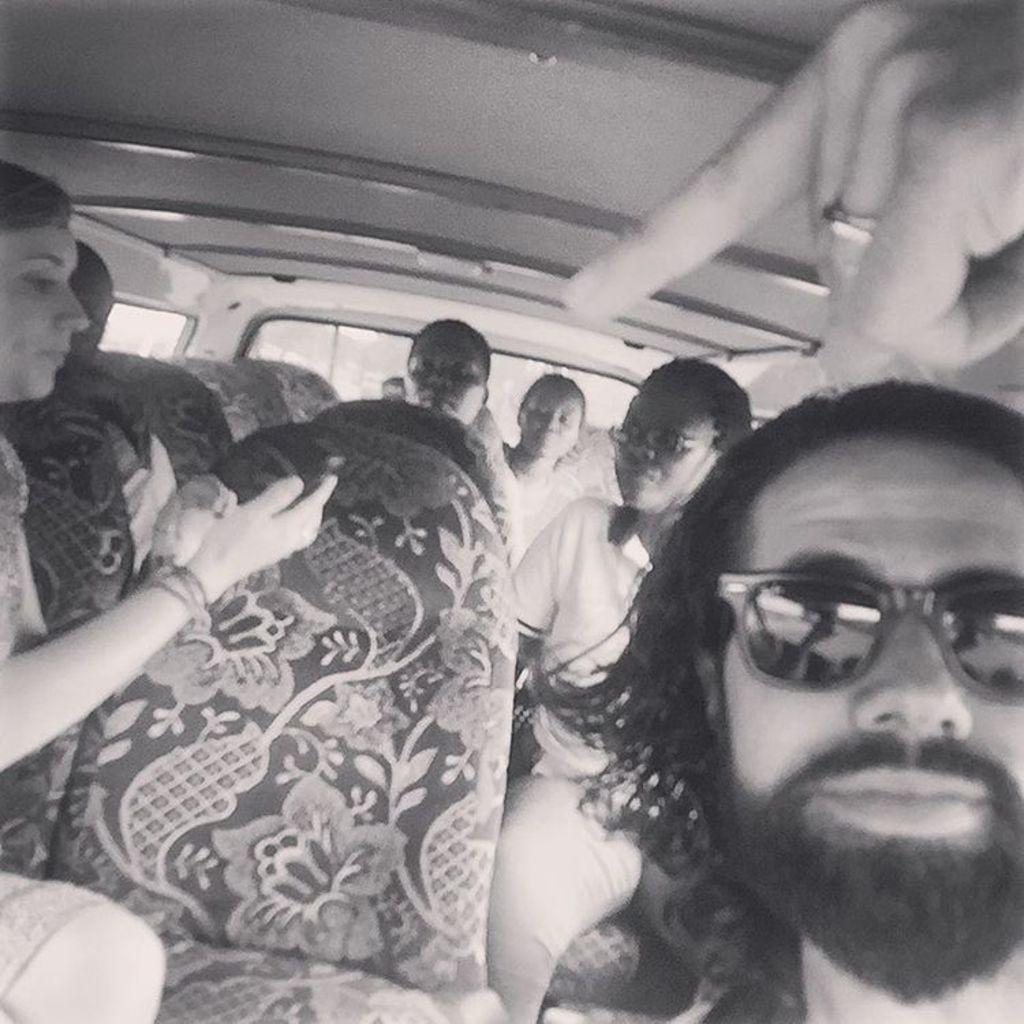Describe this image in one or two sentences. In this mobiles there are some persons sitting on the chairs in to a car as we can see there is one person on the right side is wearing goggles and the person on the left side is holding a mobile. 